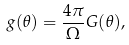<formula> <loc_0><loc_0><loc_500><loc_500>g ( \theta ) = \frac { 4 \pi } { \Omega } G ( \theta ) ,</formula> 